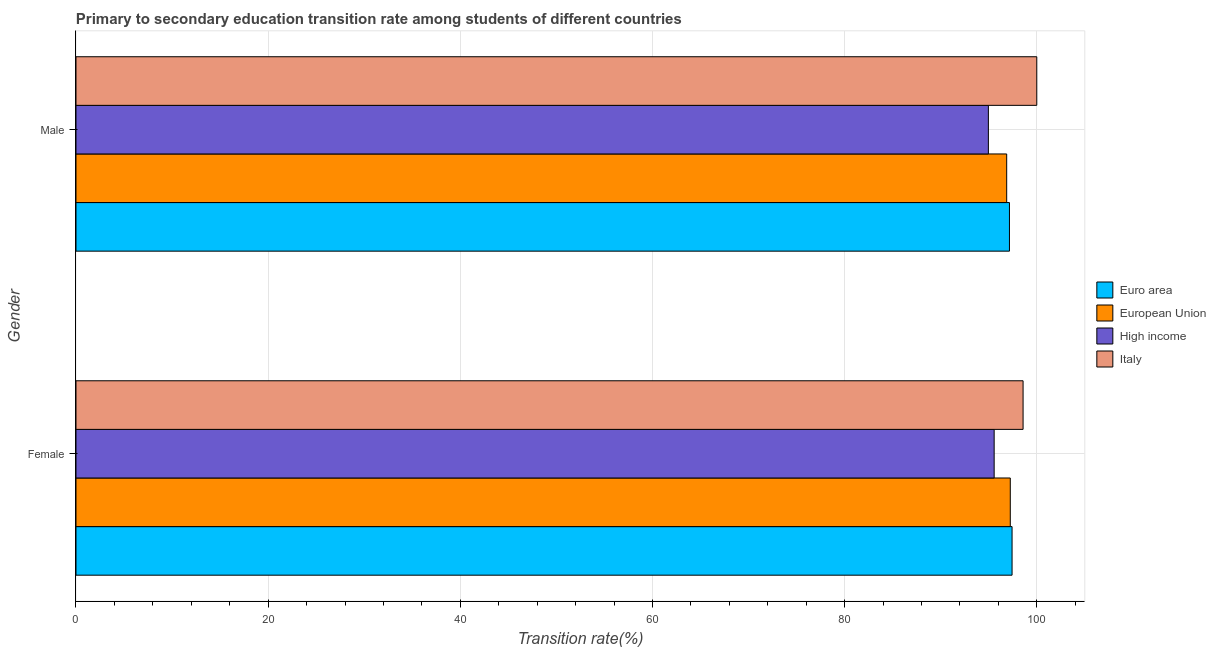How many different coloured bars are there?
Ensure brevity in your answer.  4. How many groups of bars are there?
Your answer should be very brief. 2. How many bars are there on the 2nd tick from the bottom?
Keep it short and to the point. 4. What is the transition rate among female students in European Union?
Your answer should be compact. 97.24. Across all countries, what is the maximum transition rate among female students?
Offer a terse response. 98.57. Across all countries, what is the minimum transition rate among male students?
Keep it short and to the point. 94.96. In which country was the transition rate among male students maximum?
Make the answer very short. Italy. In which country was the transition rate among male students minimum?
Ensure brevity in your answer.  High income. What is the total transition rate among female students in the graph?
Provide a succinct answer. 388.81. What is the difference between the transition rate among female students in High income and that in Euro area?
Offer a terse response. -1.86. What is the difference between the transition rate among female students in Euro area and the transition rate among male students in High income?
Your response must be concise. 2.47. What is the average transition rate among female students per country?
Give a very brief answer. 97.2. What is the difference between the transition rate among female students and transition rate among male students in Euro area?
Provide a succinct answer. 0.27. What is the ratio of the transition rate among female students in Euro area to that in Italy?
Offer a very short reply. 0.99. In how many countries, is the transition rate among male students greater than the average transition rate among male students taken over all countries?
Give a very brief answer. 1. What does the 2nd bar from the top in Female represents?
Your response must be concise. High income. What does the 4th bar from the bottom in Male represents?
Give a very brief answer. Italy. How many bars are there?
Make the answer very short. 8. Are all the bars in the graph horizontal?
Ensure brevity in your answer.  Yes. How many countries are there in the graph?
Keep it short and to the point. 4. Are the values on the major ticks of X-axis written in scientific E-notation?
Provide a succinct answer. No. Does the graph contain grids?
Your answer should be compact. Yes. What is the title of the graph?
Provide a short and direct response. Primary to secondary education transition rate among students of different countries. What is the label or title of the X-axis?
Give a very brief answer. Transition rate(%). What is the label or title of the Y-axis?
Ensure brevity in your answer.  Gender. What is the Transition rate(%) of Euro area in Female?
Ensure brevity in your answer.  97.43. What is the Transition rate(%) in European Union in Female?
Offer a terse response. 97.24. What is the Transition rate(%) of High income in Female?
Offer a terse response. 95.56. What is the Transition rate(%) of Italy in Female?
Your answer should be compact. 98.57. What is the Transition rate(%) of Euro area in Male?
Give a very brief answer. 97.16. What is the Transition rate(%) of European Union in Male?
Provide a short and direct response. 96.87. What is the Transition rate(%) of High income in Male?
Ensure brevity in your answer.  94.96. Across all Gender, what is the maximum Transition rate(%) in Euro area?
Provide a succinct answer. 97.43. Across all Gender, what is the maximum Transition rate(%) in European Union?
Your answer should be very brief. 97.24. Across all Gender, what is the maximum Transition rate(%) of High income?
Keep it short and to the point. 95.56. Across all Gender, what is the minimum Transition rate(%) of Euro area?
Keep it short and to the point. 97.16. Across all Gender, what is the minimum Transition rate(%) of European Union?
Your answer should be very brief. 96.87. Across all Gender, what is the minimum Transition rate(%) of High income?
Ensure brevity in your answer.  94.96. Across all Gender, what is the minimum Transition rate(%) of Italy?
Make the answer very short. 98.57. What is the total Transition rate(%) of Euro area in the graph?
Offer a terse response. 194.58. What is the total Transition rate(%) in European Union in the graph?
Provide a short and direct response. 194.11. What is the total Transition rate(%) of High income in the graph?
Provide a short and direct response. 190.53. What is the total Transition rate(%) in Italy in the graph?
Your answer should be very brief. 198.57. What is the difference between the Transition rate(%) in Euro area in Female and that in Male?
Your answer should be compact. 0.27. What is the difference between the Transition rate(%) of European Union in Female and that in Male?
Provide a short and direct response. 0.38. What is the difference between the Transition rate(%) of High income in Female and that in Male?
Provide a short and direct response. 0.6. What is the difference between the Transition rate(%) in Italy in Female and that in Male?
Make the answer very short. -1.43. What is the difference between the Transition rate(%) of Euro area in Female and the Transition rate(%) of European Union in Male?
Provide a succinct answer. 0.56. What is the difference between the Transition rate(%) of Euro area in Female and the Transition rate(%) of High income in Male?
Provide a succinct answer. 2.47. What is the difference between the Transition rate(%) of Euro area in Female and the Transition rate(%) of Italy in Male?
Provide a succinct answer. -2.57. What is the difference between the Transition rate(%) in European Union in Female and the Transition rate(%) in High income in Male?
Your response must be concise. 2.28. What is the difference between the Transition rate(%) of European Union in Female and the Transition rate(%) of Italy in Male?
Offer a terse response. -2.76. What is the difference between the Transition rate(%) in High income in Female and the Transition rate(%) in Italy in Male?
Your answer should be compact. -4.44. What is the average Transition rate(%) in Euro area per Gender?
Provide a short and direct response. 97.29. What is the average Transition rate(%) of European Union per Gender?
Your answer should be very brief. 97.05. What is the average Transition rate(%) in High income per Gender?
Provide a short and direct response. 95.26. What is the average Transition rate(%) of Italy per Gender?
Your response must be concise. 99.29. What is the difference between the Transition rate(%) of Euro area and Transition rate(%) of European Union in Female?
Your answer should be compact. 0.19. What is the difference between the Transition rate(%) of Euro area and Transition rate(%) of High income in Female?
Provide a succinct answer. 1.86. What is the difference between the Transition rate(%) in Euro area and Transition rate(%) in Italy in Female?
Provide a short and direct response. -1.15. What is the difference between the Transition rate(%) in European Union and Transition rate(%) in High income in Female?
Offer a very short reply. 1.68. What is the difference between the Transition rate(%) in European Union and Transition rate(%) in Italy in Female?
Make the answer very short. -1.33. What is the difference between the Transition rate(%) in High income and Transition rate(%) in Italy in Female?
Your response must be concise. -3.01. What is the difference between the Transition rate(%) in Euro area and Transition rate(%) in European Union in Male?
Your answer should be compact. 0.29. What is the difference between the Transition rate(%) of Euro area and Transition rate(%) of High income in Male?
Ensure brevity in your answer.  2.19. What is the difference between the Transition rate(%) of Euro area and Transition rate(%) of Italy in Male?
Your answer should be compact. -2.84. What is the difference between the Transition rate(%) of European Union and Transition rate(%) of High income in Male?
Offer a terse response. 1.91. What is the difference between the Transition rate(%) in European Union and Transition rate(%) in Italy in Male?
Offer a very short reply. -3.13. What is the difference between the Transition rate(%) of High income and Transition rate(%) of Italy in Male?
Provide a short and direct response. -5.04. What is the ratio of the Transition rate(%) in Euro area in Female to that in Male?
Make the answer very short. 1. What is the ratio of the Transition rate(%) of Italy in Female to that in Male?
Provide a succinct answer. 0.99. What is the difference between the highest and the second highest Transition rate(%) of Euro area?
Offer a very short reply. 0.27. What is the difference between the highest and the second highest Transition rate(%) in European Union?
Provide a short and direct response. 0.38. What is the difference between the highest and the second highest Transition rate(%) in High income?
Provide a succinct answer. 0.6. What is the difference between the highest and the second highest Transition rate(%) of Italy?
Ensure brevity in your answer.  1.43. What is the difference between the highest and the lowest Transition rate(%) in Euro area?
Offer a terse response. 0.27. What is the difference between the highest and the lowest Transition rate(%) in European Union?
Your response must be concise. 0.38. What is the difference between the highest and the lowest Transition rate(%) of High income?
Your answer should be compact. 0.6. What is the difference between the highest and the lowest Transition rate(%) of Italy?
Make the answer very short. 1.43. 